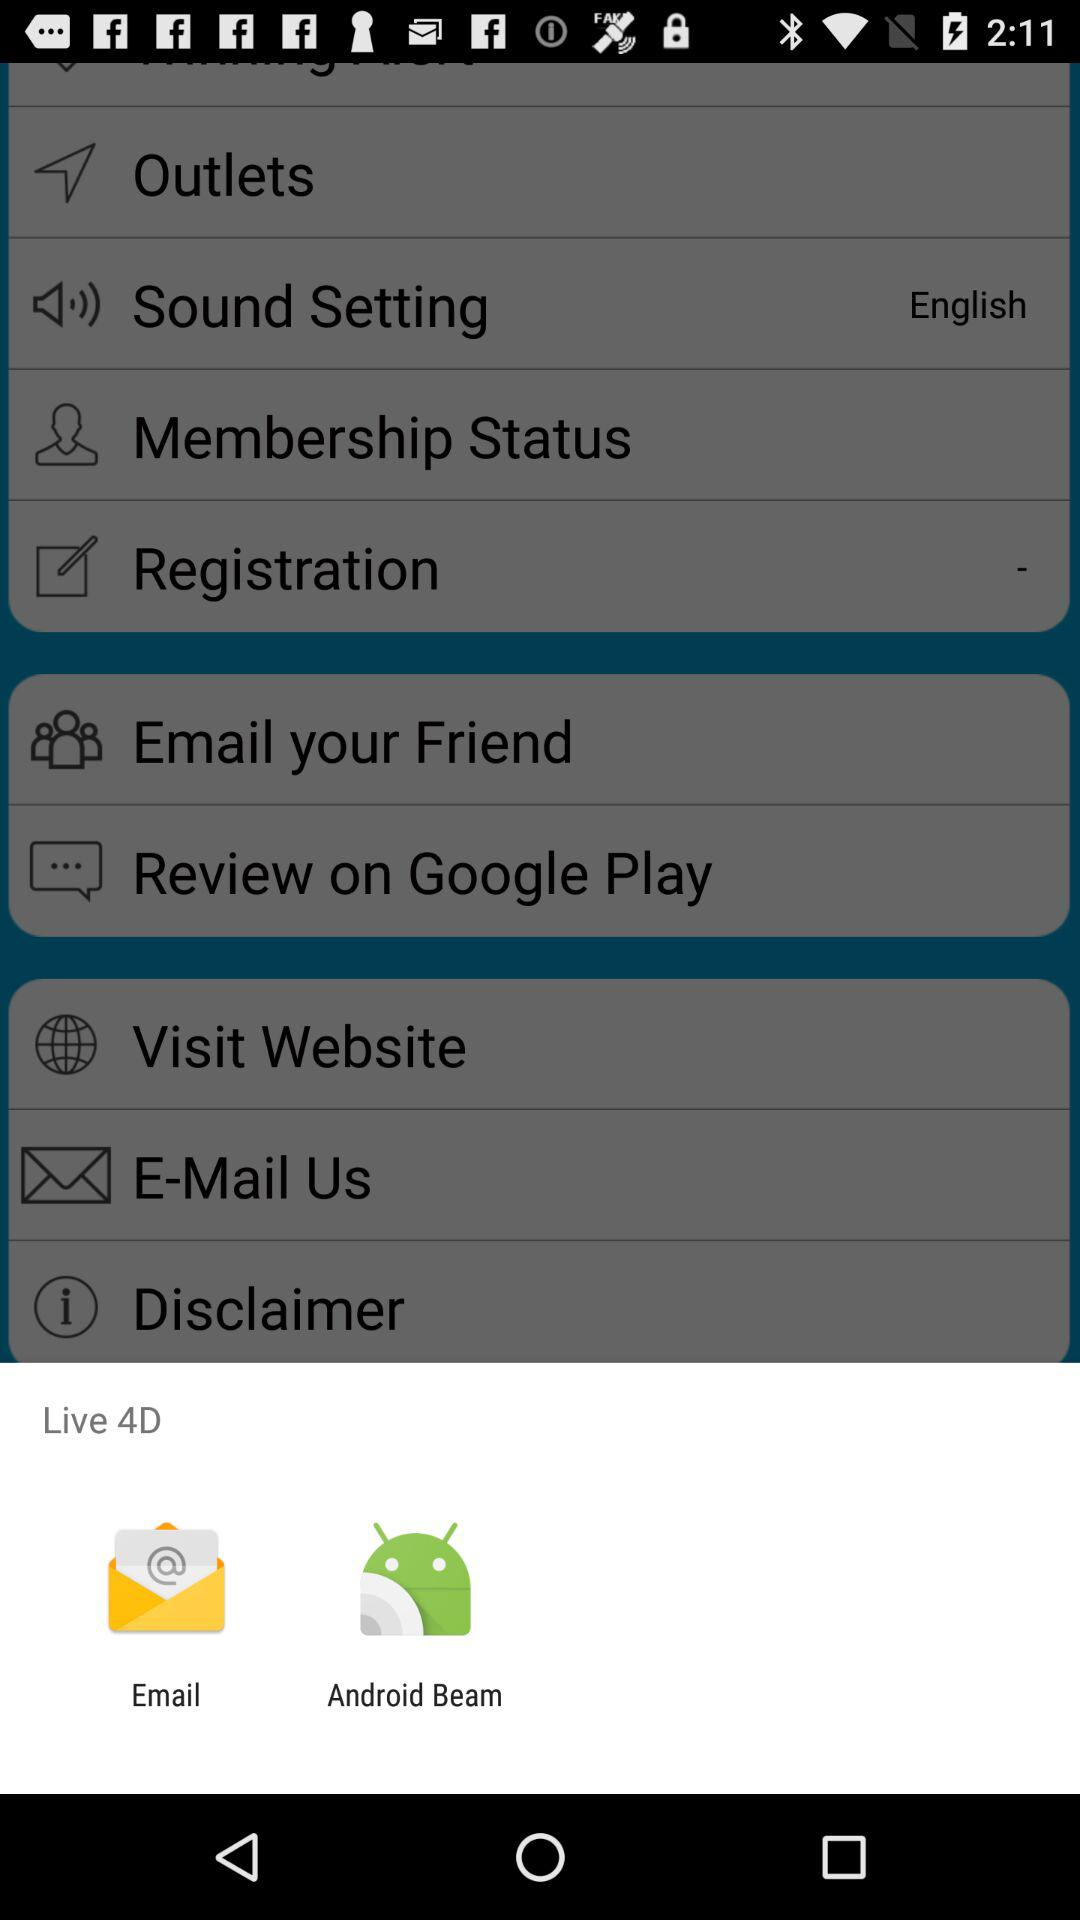What's the sound setting? The sound setting is "English". 